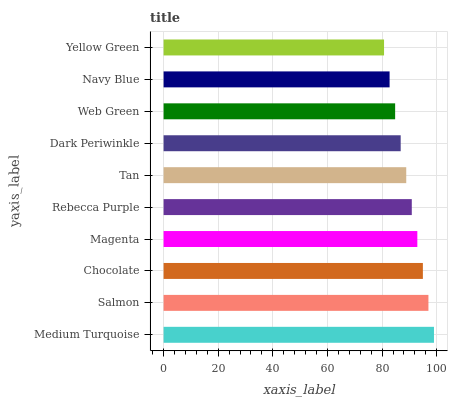Is Yellow Green the minimum?
Answer yes or no. Yes. Is Medium Turquoise the maximum?
Answer yes or no. Yes. Is Salmon the minimum?
Answer yes or no. No. Is Salmon the maximum?
Answer yes or no. No. Is Medium Turquoise greater than Salmon?
Answer yes or no. Yes. Is Salmon less than Medium Turquoise?
Answer yes or no. Yes. Is Salmon greater than Medium Turquoise?
Answer yes or no. No. Is Medium Turquoise less than Salmon?
Answer yes or no. No. Is Rebecca Purple the high median?
Answer yes or no. Yes. Is Tan the low median?
Answer yes or no. Yes. Is Yellow Green the high median?
Answer yes or no. No. Is Chocolate the low median?
Answer yes or no. No. 